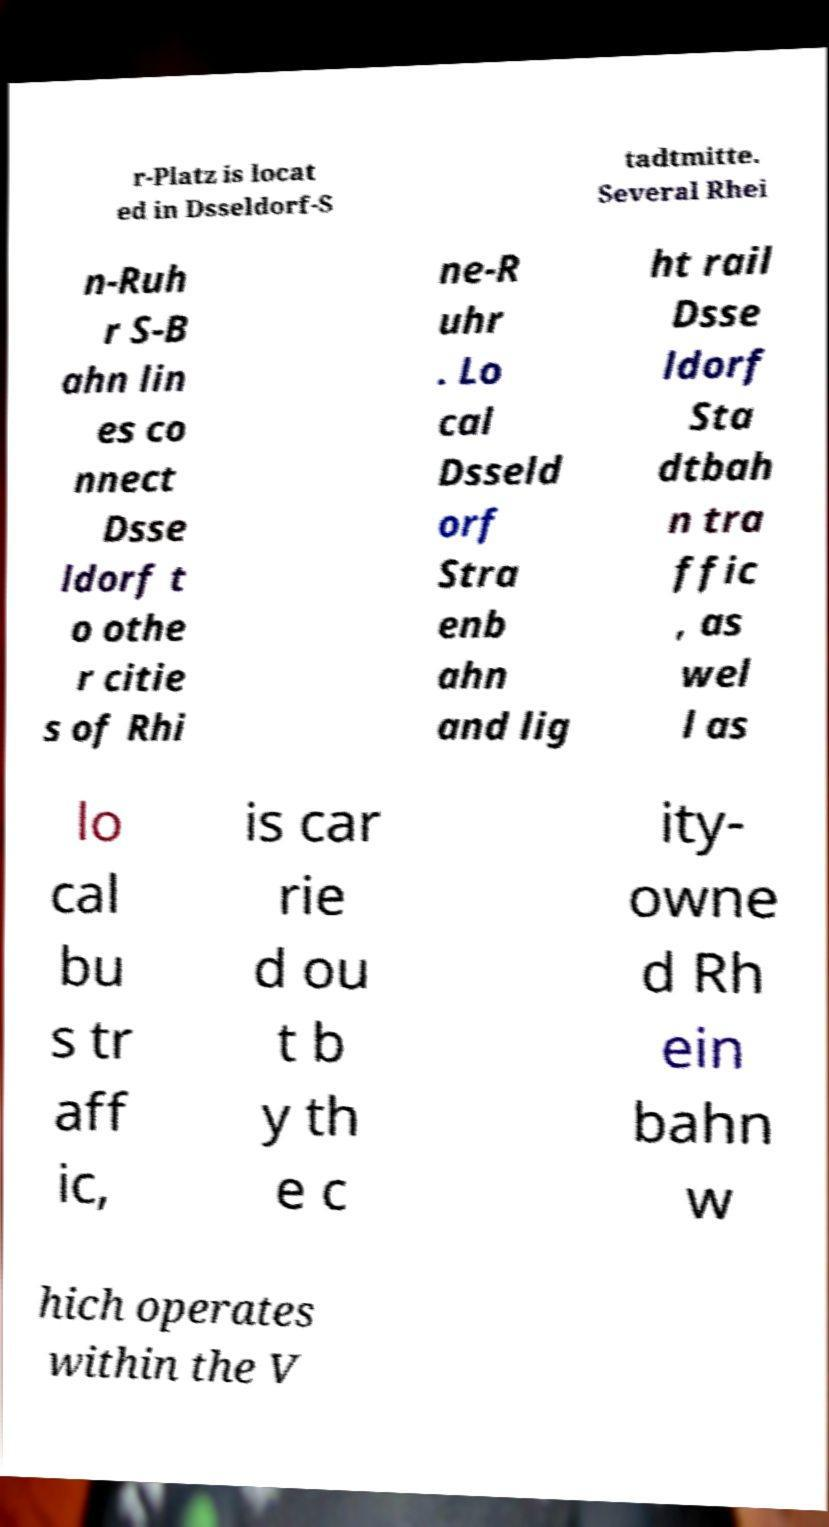Could you extract and type out the text from this image? r-Platz is locat ed in Dsseldorf-S tadtmitte. Several Rhei n-Ruh r S-B ahn lin es co nnect Dsse ldorf t o othe r citie s of Rhi ne-R uhr . Lo cal Dsseld orf Stra enb ahn and lig ht rail Dsse ldorf Sta dtbah n tra ffic , as wel l as lo cal bu s tr aff ic, is car rie d ou t b y th e c ity- owne d Rh ein bahn w hich operates within the V 